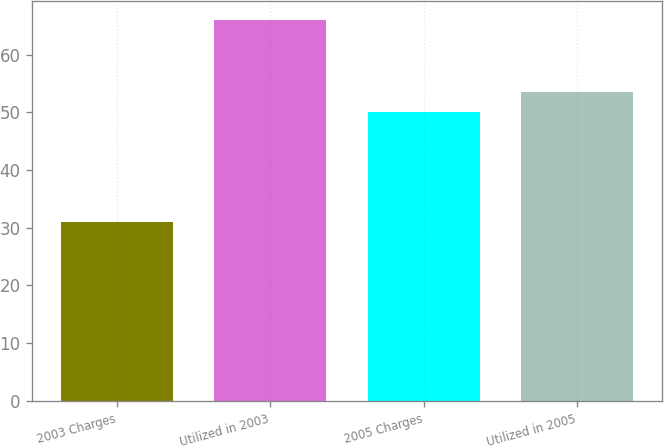Convert chart. <chart><loc_0><loc_0><loc_500><loc_500><bar_chart><fcel>2003 Charges<fcel>Utilized in 2003<fcel>2005 Charges<fcel>Utilized in 2005<nl><fcel>31<fcel>66<fcel>50<fcel>53.5<nl></chart> 